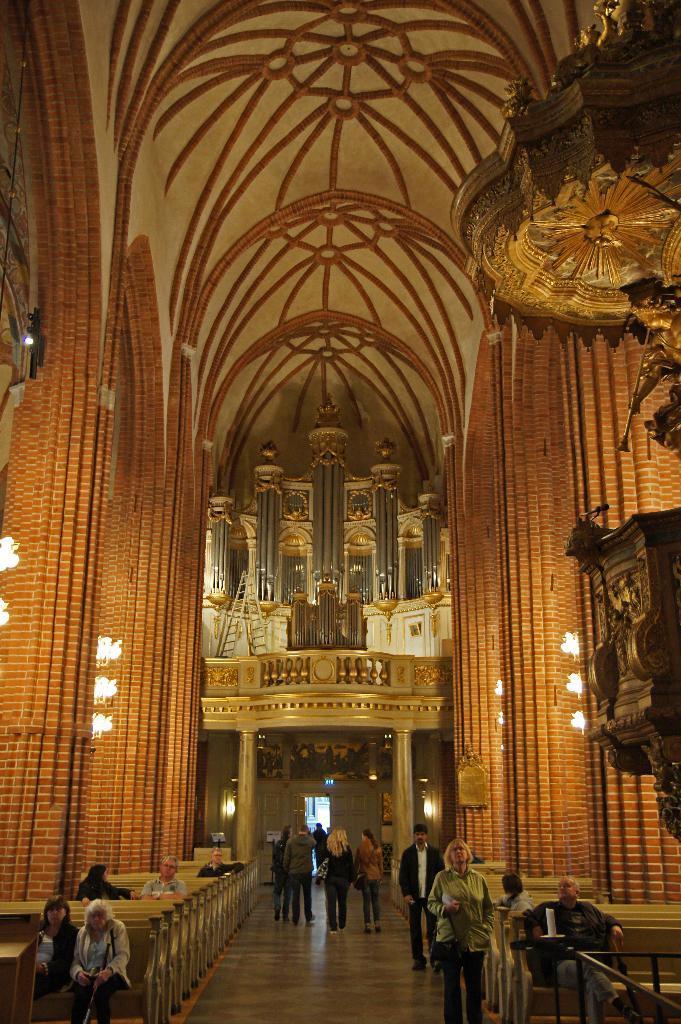In one or two sentences, can you explain what this image depicts? In this image there are a few people sitting in chairs and there are a few people walking in a big hall, around the hall there are lamps on the pillars, in the background of the image there is an entrance door, on top of it there is some architectural designs on the walls. 